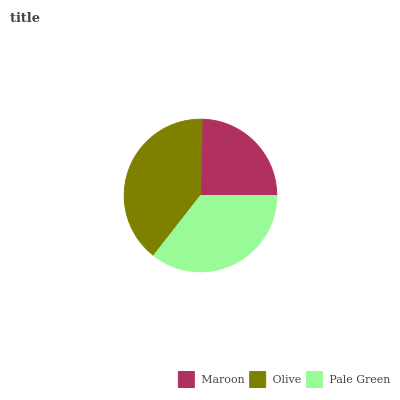Is Maroon the minimum?
Answer yes or no. Yes. Is Olive the maximum?
Answer yes or no. Yes. Is Pale Green the minimum?
Answer yes or no. No. Is Pale Green the maximum?
Answer yes or no. No. Is Olive greater than Pale Green?
Answer yes or no. Yes. Is Pale Green less than Olive?
Answer yes or no. Yes. Is Pale Green greater than Olive?
Answer yes or no. No. Is Olive less than Pale Green?
Answer yes or no. No. Is Pale Green the high median?
Answer yes or no. Yes. Is Pale Green the low median?
Answer yes or no. Yes. Is Olive the high median?
Answer yes or no. No. Is Maroon the low median?
Answer yes or no. No. 